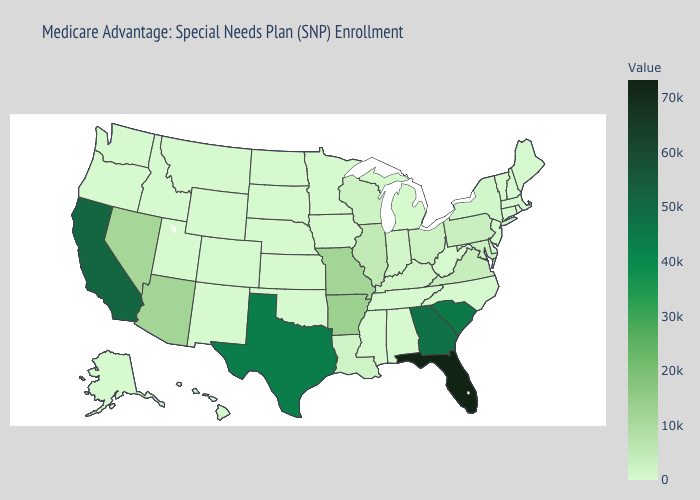Among the states that border Texas , which have the lowest value?
Keep it brief. New Mexico, Oklahoma. Does Delaware have the highest value in the South?
Write a very short answer. No. Does Georgia have a higher value than Florida?
Concise answer only. No. 